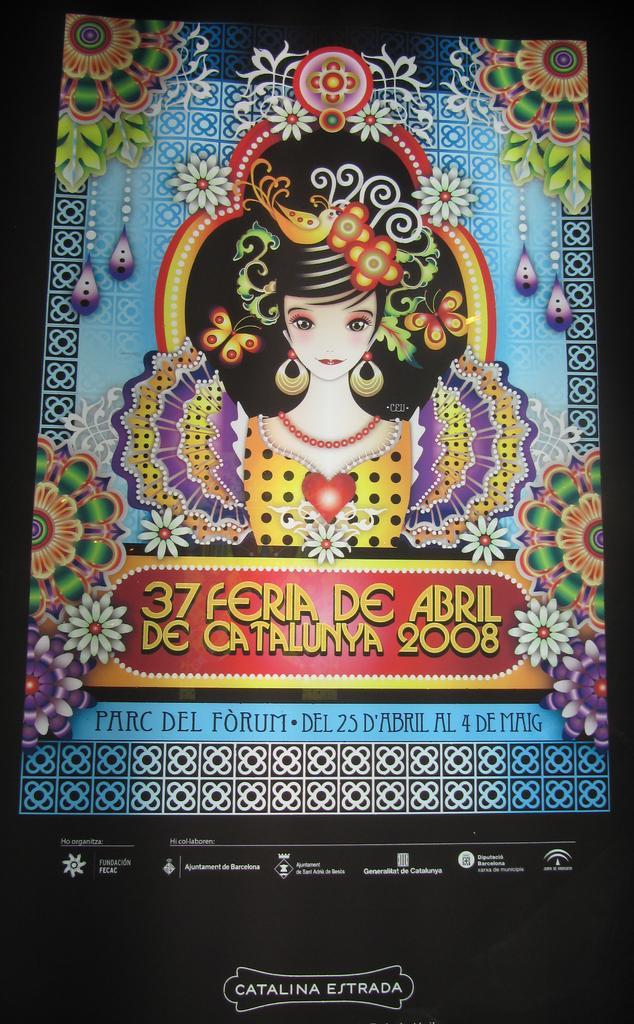In one or two sentences, can you explain what this image depicts? This might be an animation, in this image in the center there is one person and also there are some decorations. And at the bottom of the image there is some text, and in the center also there is some text. 